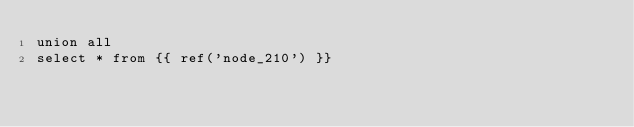<code> <loc_0><loc_0><loc_500><loc_500><_SQL_>union all
select * from {{ ref('node_210') }}
</code> 